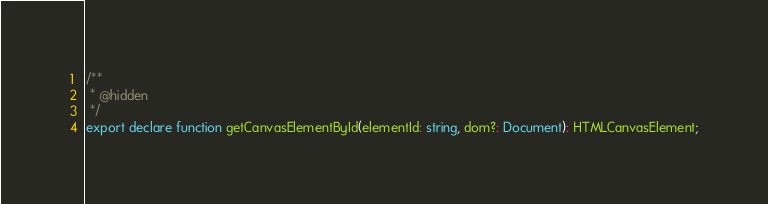Convert code to text. <code><loc_0><loc_0><loc_500><loc_500><_TypeScript_>/**
 * @hidden
 */
export declare function getCanvasElementById(elementId: string, dom?: Document): HTMLCanvasElement;
</code> 